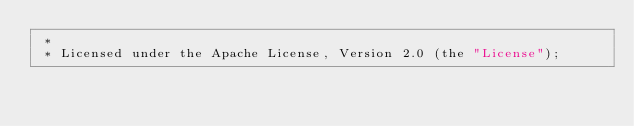Convert code to text. <code><loc_0><loc_0><loc_500><loc_500><_Kotlin_> *
 * Licensed under the Apache License, Version 2.0 (the "License");</code> 